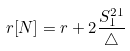<formula> <loc_0><loc_0><loc_500><loc_500>r [ N ] = r + 2 \frac { S _ { 1 } ^ { 2 1 } } { \triangle }</formula> 